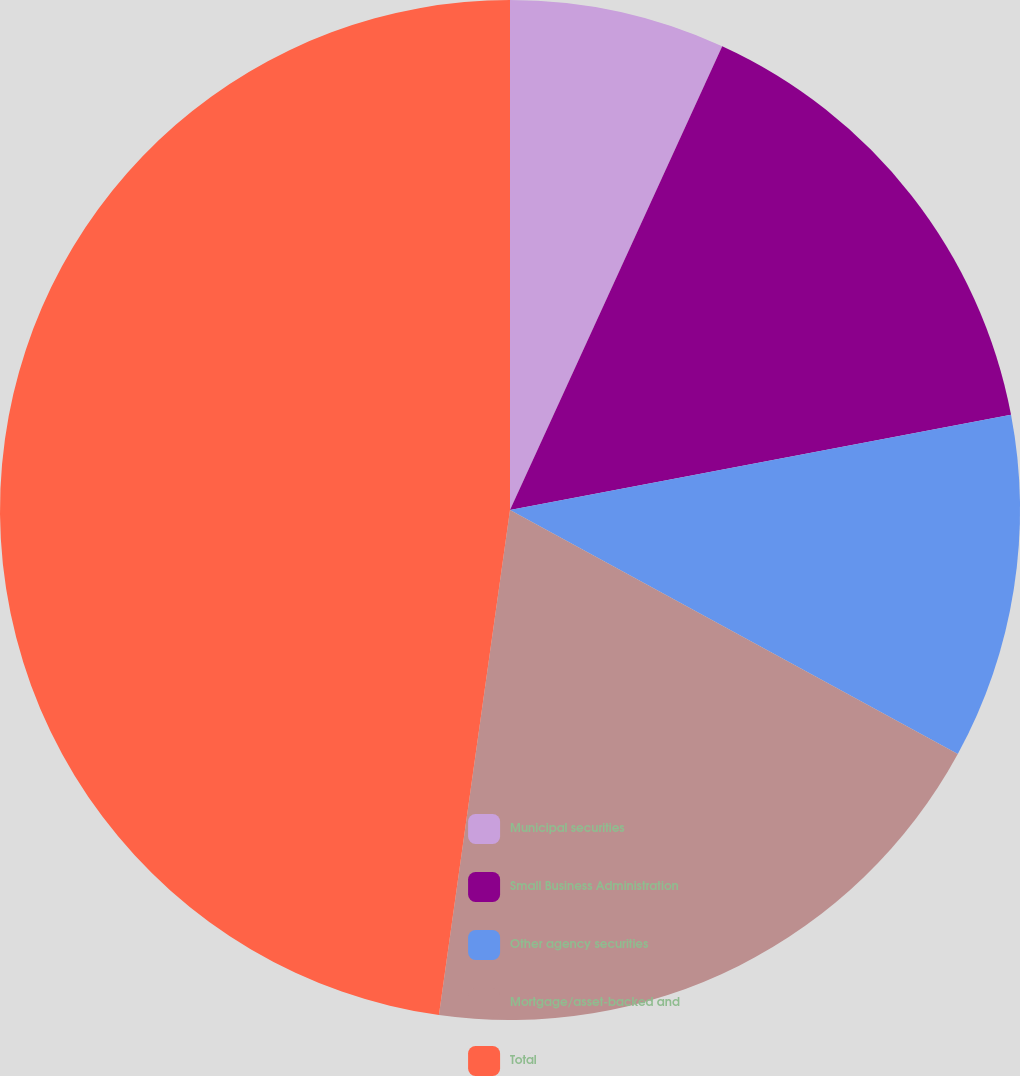<chart> <loc_0><loc_0><loc_500><loc_500><pie_chart><fcel>Municipal securities<fcel>Small Business Administration<fcel>Other agency securities<fcel>Mortgage/asset-backed and<fcel>Total<nl><fcel>6.83%<fcel>15.18%<fcel>10.93%<fcel>19.28%<fcel>47.77%<nl></chart> 